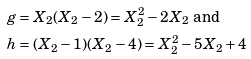Convert formula to latex. <formula><loc_0><loc_0><loc_500><loc_500>g & = X _ { 2 } ( X _ { 2 } - 2 ) = X _ { 2 } ^ { 2 } - 2 X _ { 2 } \text { and } \\ h & = ( X _ { 2 } - 1 ) ( X _ { 2 } - 4 ) = X _ { 2 } ^ { 2 } - 5 X _ { 2 } + 4</formula> 